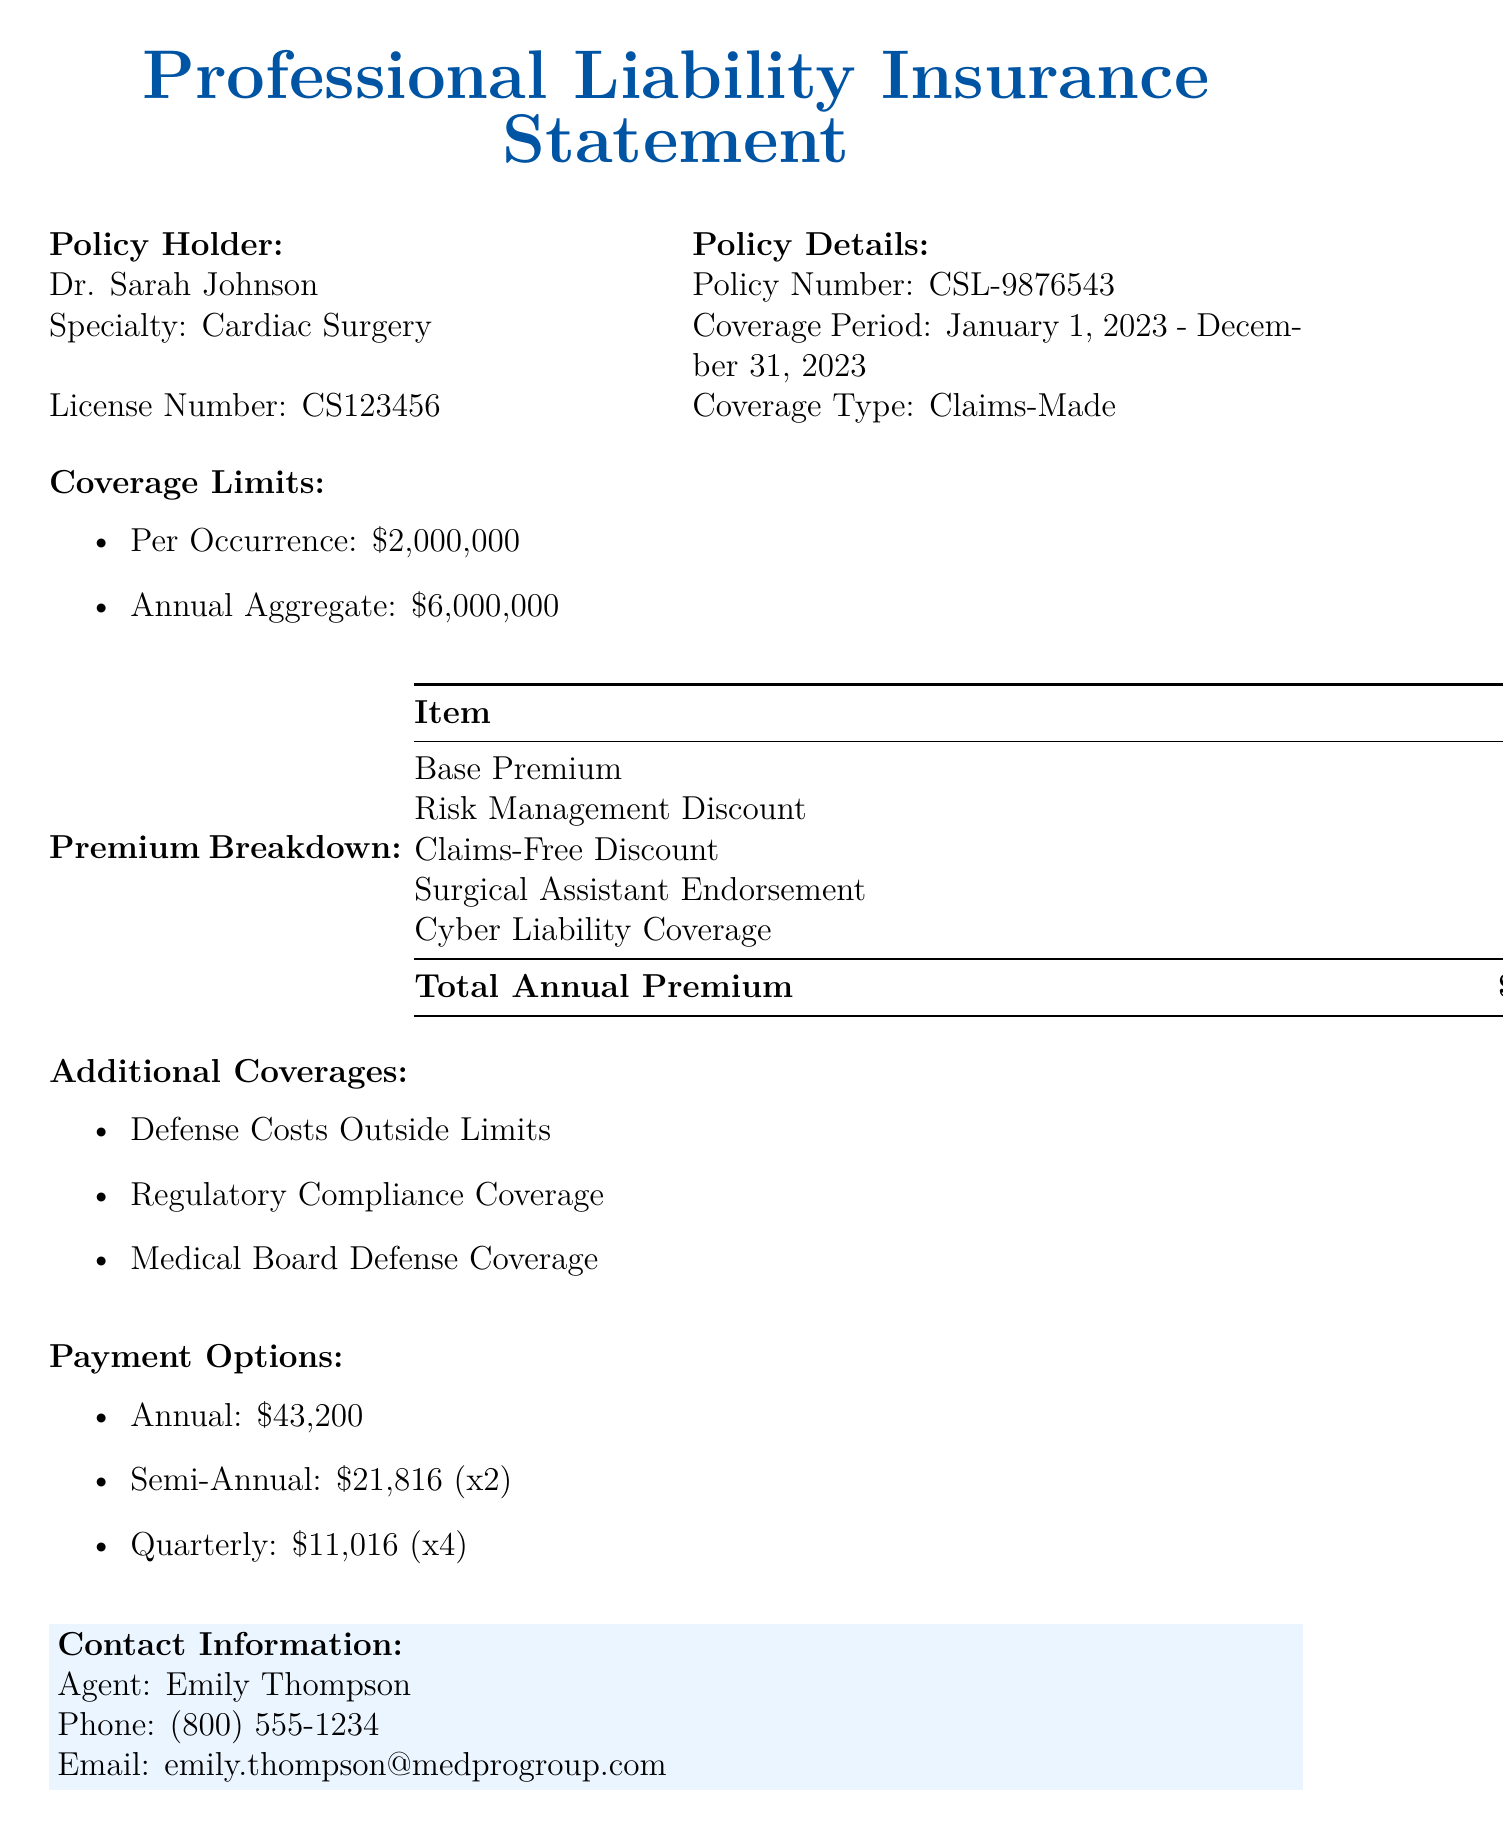What is the policy number? The policy number is listed in the document under policy details, which is CSL-9876543.
Answer: CSL-9876543 What is the total annual premium? The total annual premium is calculated from the premium breakdown and is stated in the document as \$43,200.00.
Answer: \$43,200.00 What are the defense costs outside limits? This is mentioned in the document as one of the additional coverages provided in the policy.
Answer: Defense Costs Outside Limits What is the per occurrence coverage limit? The per occurrence coverage limit is found in the coverage limits section, which specifies \$2,000,000.
Answer: \$2,000,000 How much is the claims-free discount? The claims-free discount is listed under premium breakdown and amounts to \$1,800.00.
Answer: \$1,800.00 Who is the contact agent? The contact agent's name is provided in the contact information section of the document, which is Emily Thompson.
Answer: Emily Thompson What coverage type is listed for this policy? The coverage type is indicated in the policy details section and is identified as Claims-Made.
Answer: Claims-Made What is the coverage period? The coverage period is mentioned in the policy details and spans from January 1, 2023 to December 31, 2023.
Answer: January 1, 2023 - December 31, 2023 How many payment options are provided? The document states three payment options available to the policyholder.
Answer: Three 